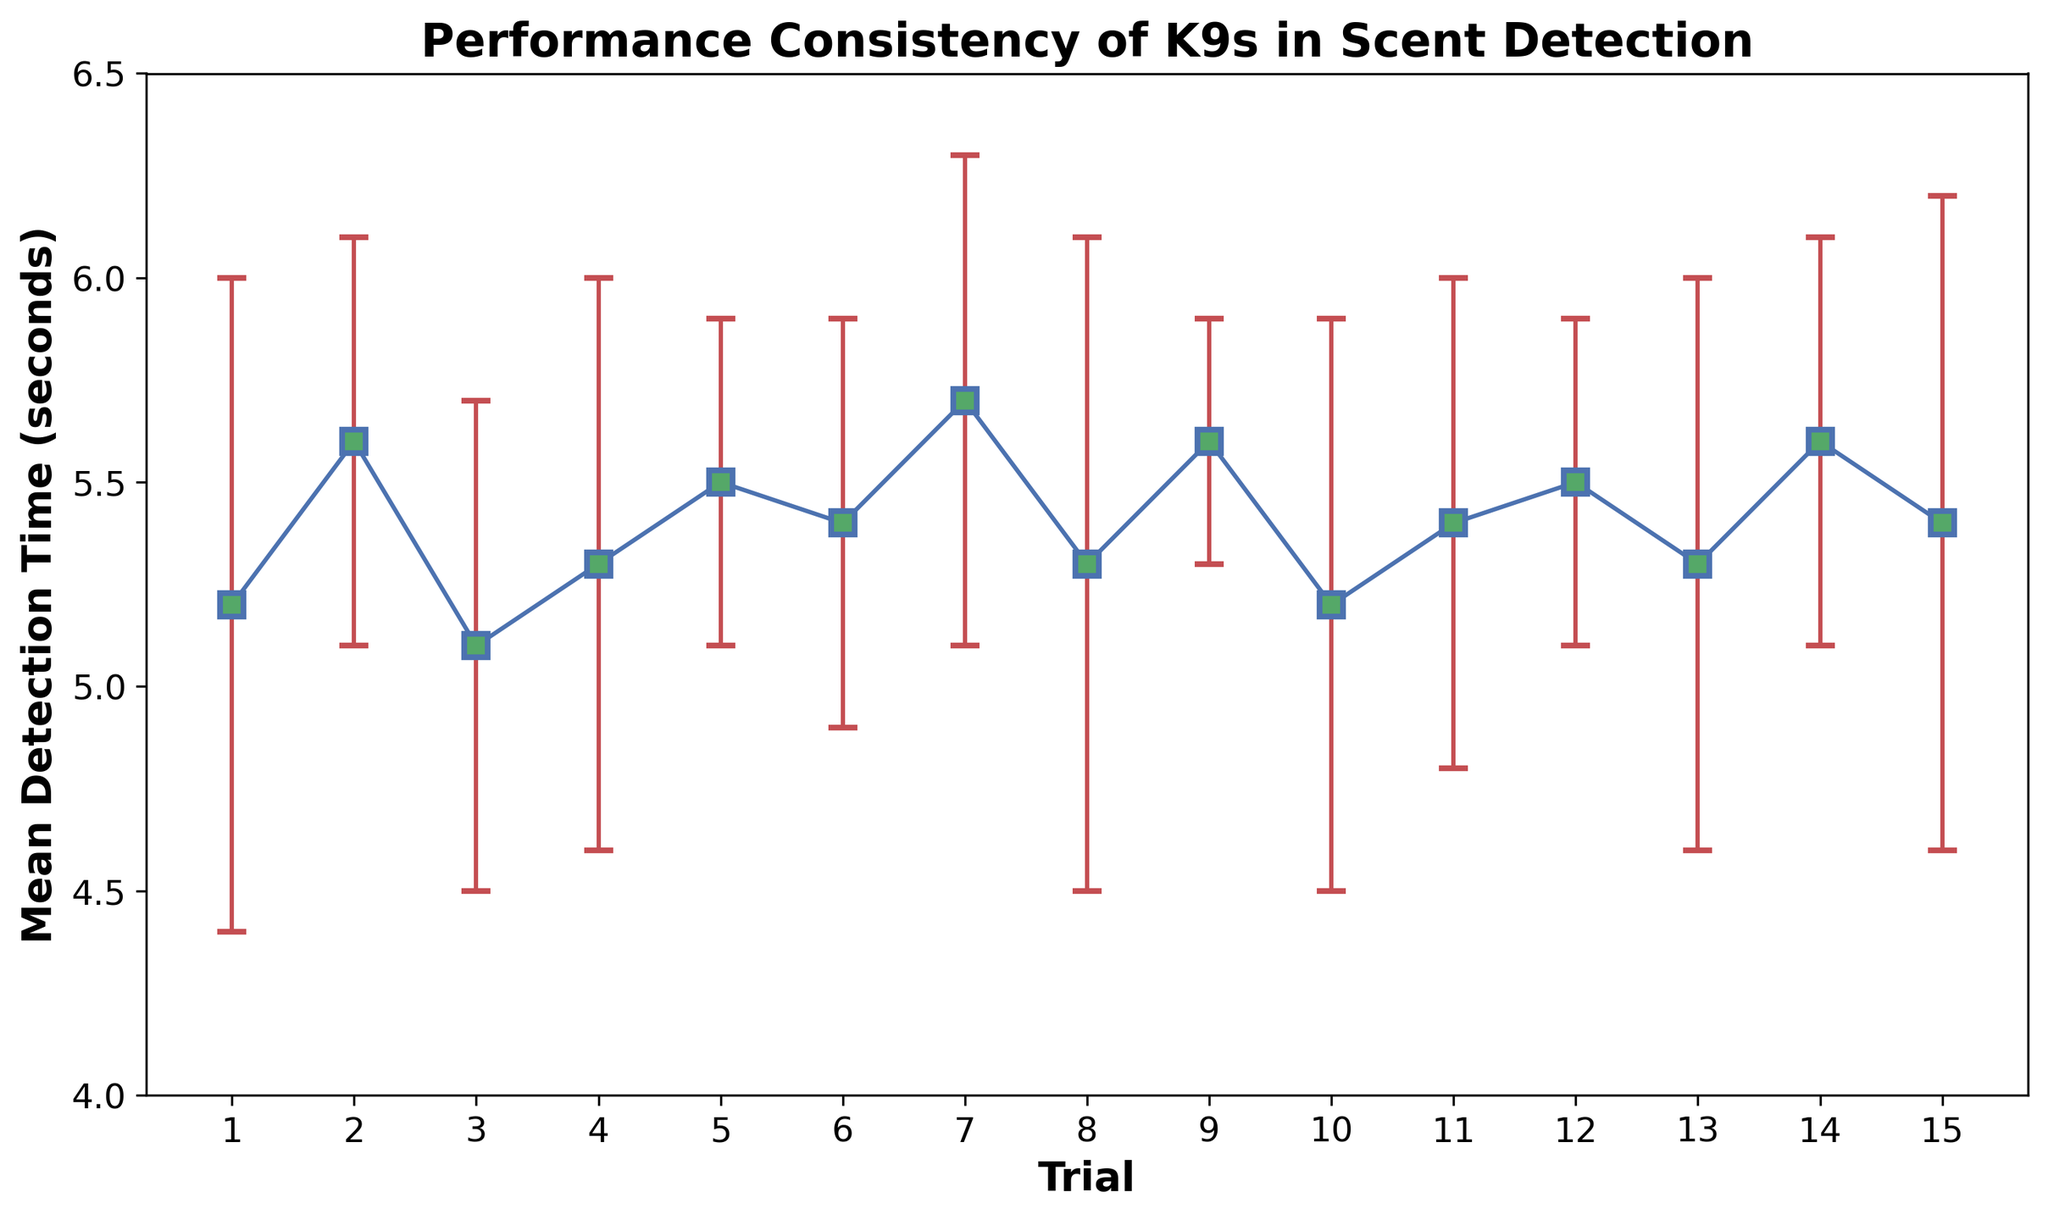What is the mean detection time for trial 7? Look at the data point corresponding to trial 7 on the x-axis and read the mean detection time on the y-axis.
Answer: 5.7 seconds Which trial has the smallest variability in detection time? Compare the error bars (representing standard deviations) for each trial and identify the shortest one. Trial 9 has the smallest standard deviation of 0.3 seconds.
Answer: Trial 9 How does the mean detection time in trial 10 compare to trial 1? Check the mean detection times for trials 10 and 1: both are 5.2 seconds; they are equal.
Answer: Equal What is the average detection time across all trials? Sum the mean detection times for all trials and divide by the number of trials: (sum of all mean detection times)/15. The sum of mean detection times is 79.8, so 79.8/15 = 5.32.
Answer: 5.32 seconds Which trial shows the highest mean detection time, and what is it? Identify the trial with the highest y-axis value for mean detection time. Trial 7 has the highest mean detection time of 5.7 seconds.
Answer: Trial 7 at 5.7 seconds What is the range of detection times considering the error bars? For each trial, add and subtract the standard deviation from the mean detection time to find the range for each. The maximum range is between 6.3 seconds (trial 7: 5.7+0.6) and 4.4 seconds (trials 3 and 10: 5.1-0.6 and 5.2-0.8, respectively).
Answer: 4.4 to 6.3 seconds Between which trials is the change in mean detection time the greatest? Calculate the absolute differences between consecutive trials' mean detection times; the greatest change is between trials 6 and 7 (5.4 to 5.7), and between trials 2 and 3 (5.6 to 5.1).
Answer: Trials 2 and 3 or Trials 6 and 7 What is the average standard deviation across all trials? Sum all the standard deviations and divide by the number of trials. The sum of standard deviations is 8.2, so 8.2/15 = 0.546.
Answer: 0.55 